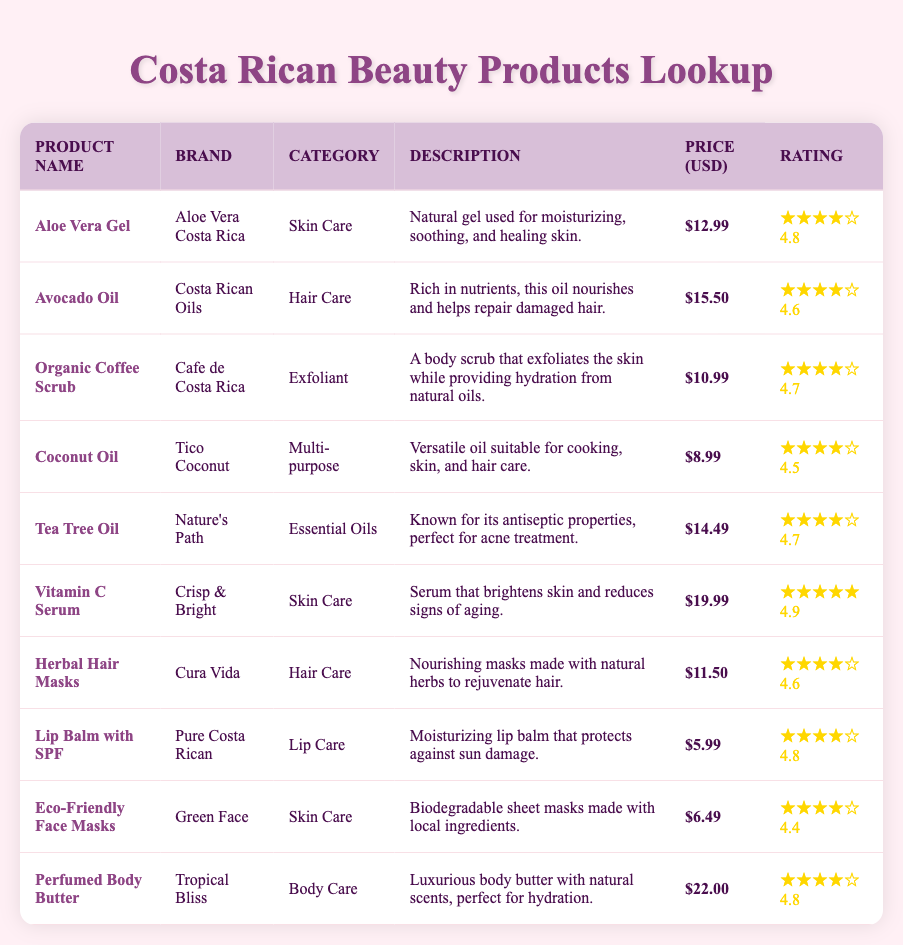What is the price of the Aloe Vera Gel? The price of the Aloe Vera Gel is listed in the table as $12.99.
Answer: 12.99 Which product has the highest popularity rating? Upon reviewing all products, the Vitamin C Serum has the highest rating of 4.9, which is indicated in the rating column.
Answer: Vitamin C Serum Is the Organic Coffee Scrub more expensive than the Coconut Oil? The price of the Organic Coffee Scrub is $10.99, while the Coconut Oil is $8.99. Therefore, $10.99 is greater than $8.99, confirming that it is more expensive.
Answer: Yes How many hair care products are listed in the table? The table shows two hair care products: Avocado Oil and Herbal Hair Masks. Counting them gives a total of 2.
Answer: 2 What is the average price of all the skin care products? The skin care products listed are Aloe Vera Gel ($12.99), Vitamin C Serum ($19.99), and Eco-Friendly Face Masks ($6.49). Their total price is $12.99 + $19.99 + $6.49 = $39.47. There are 3 skin care products, so the average price is $39.47 / 3 = $13.16.
Answer: 13.16 Does the Lip Balm with SPF have a higher rating than the Herbal Hair Masks? The Lip Balm with SPF has a rating of 4.8, while the Herbal Hair Masks has a rating of 4.6. Since 4.8 > 4.6, it confirms that the Lip Balm has a higher rating.
Answer: Yes What is the description of the Perfumed Body Butter? The table describes the Perfumed Body Butter as a luxurious body butter with natural scents, perfect for hydration. This is detailed in the description column.
Answer: Luxurious body butter with natural scents, perfect for hydration What is the difference in popularity rating between the Coconut Oil and the Tea Tree Oil? The Coconut Oil has a rating of 4.5, and the Tea Tree Oil has a rating of 4.7. The difference is calculated as 4.7 - 4.5 = 0.2, showing that the Tea Tree Oil is rated higher by this amount.
Answer: 0.2 Which product has the lowest price? The Coconut Oil is priced at $8.99, which is lower than all other products listed, making it the least expensive item.
Answer: Coconut Oil 